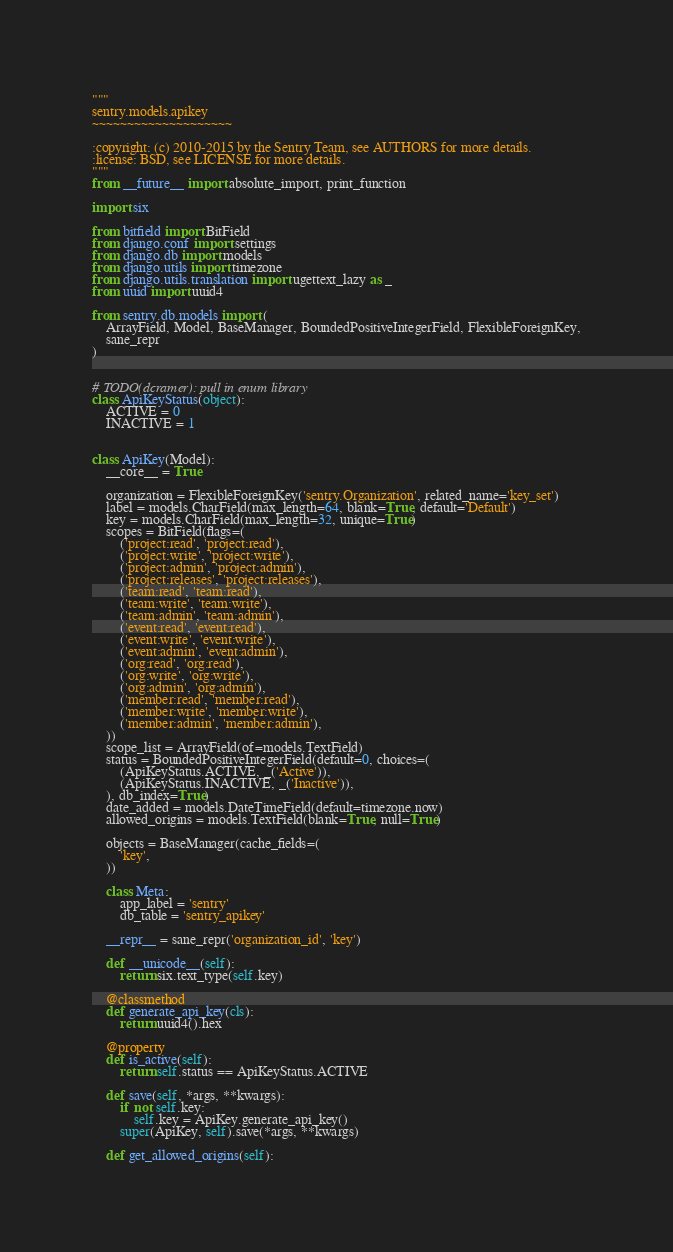<code> <loc_0><loc_0><loc_500><loc_500><_Python_>"""
sentry.models.apikey
~~~~~~~~~~~~~~~~~~~~

:copyright: (c) 2010-2015 by the Sentry Team, see AUTHORS for more details.
:license: BSD, see LICENSE for more details.
"""
from __future__ import absolute_import, print_function

import six

from bitfield import BitField
from django.conf import settings
from django.db import models
from django.utils import timezone
from django.utils.translation import ugettext_lazy as _
from uuid import uuid4

from sentry.db.models import (
    ArrayField, Model, BaseManager, BoundedPositiveIntegerField, FlexibleForeignKey,
    sane_repr
)


# TODO(dcramer): pull in enum library
class ApiKeyStatus(object):
    ACTIVE = 0
    INACTIVE = 1


class ApiKey(Model):
    __core__ = True

    organization = FlexibleForeignKey('sentry.Organization', related_name='key_set')
    label = models.CharField(max_length=64, blank=True, default='Default')
    key = models.CharField(max_length=32, unique=True)
    scopes = BitField(flags=(
        ('project:read', 'project:read'),
        ('project:write', 'project:write'),
        ('project:admin', 'project:admin'),
        ('project:releases', 'project:releases'),
        ('team:read', 'team:read'),
        ('team:write', 'team:write'),
        ('team:admin', 'team:admin'),
        ('event:read', 'event:read'),
        ('event:write', 'event:write'),
        ('event:admin', 'event:admin'),
        ('org:read', 'org:read'),
        ('org:write', 'org:write'),
        ('org:admin', 'org:admin'),
        ('member:read', 'member:read'),
        ('member:write', 'member:write'),
        ('member:admin', 'member:admin'),
    ))
    scope_list = ArrayField(of=models.TextField)
    status = BoundedPositiveIntegerField(default=0, choices=(
        (ApiKeyStatus.ACTIVE, _('Active')),
        (ApiKeyStatus.INACTIVE, _('Inactive')),
    ), db_index=True)
    date_added = models.DateTimeField(default=timezone.now)
    allowed_origins = models.TextField(blank=True, null=True)

    objects = BaseManager(cache_fields=(
        'key',
    ))

    class Meta:
        app_label = 'sentry'
        db_table = 'sentry_apikey'

    __repr__ = sane_repr('organization_id', 'key')

    def __unicode__(self):
        return six.text_type(self.key)

    @classmethod
    def generate_api_key(cls):
        return uuid4().hex

    @property
    def is_active(self):
        return self.status == ApiKeyStatus.ACTIVE

    def save(self, *args, **kwargs):
        if not self.key:
            self.key = ApiKey.generate_api_key()
        super(ApiKey, self).save(*args, **kwargs)

    def get_allowed_origins(self):</code> 